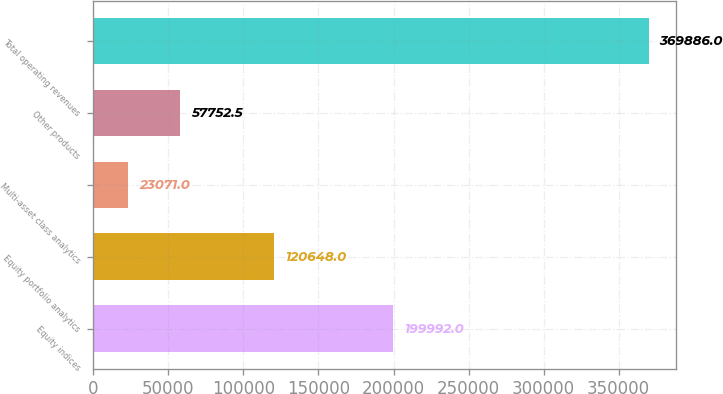<chart> <loc_0><loc_0><loc_500><loc_500><bar_chart><fcel>Equity indices<fcel>Equity portfolio analytics<fcel>Multi-asset class analytics<fcel>Other products<fcel>Total operating revenues<nl><fcel>199992<fcel>120648<fcel>23071<fcel>57752.5<fcel>369886<nl></chart> 